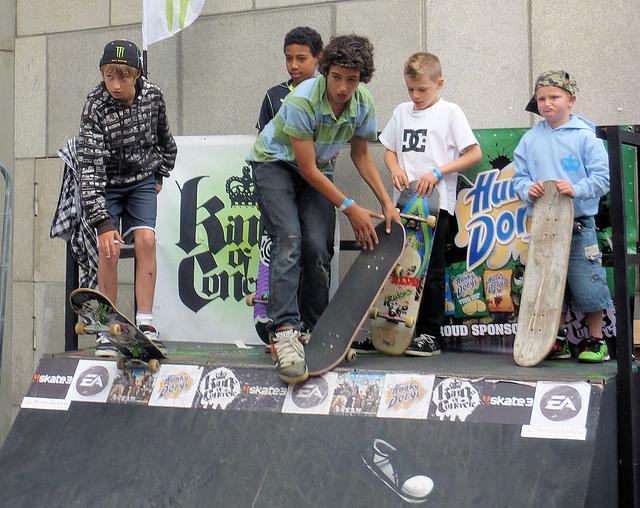How many skateboards are visible?
Give a very brief answer. 4. How many skateboards are there?
Give a very brief answer. 4. How many people are there?
Give a very brief answer. 5. How many chairs are there?
Give a very brief answer. 0. 